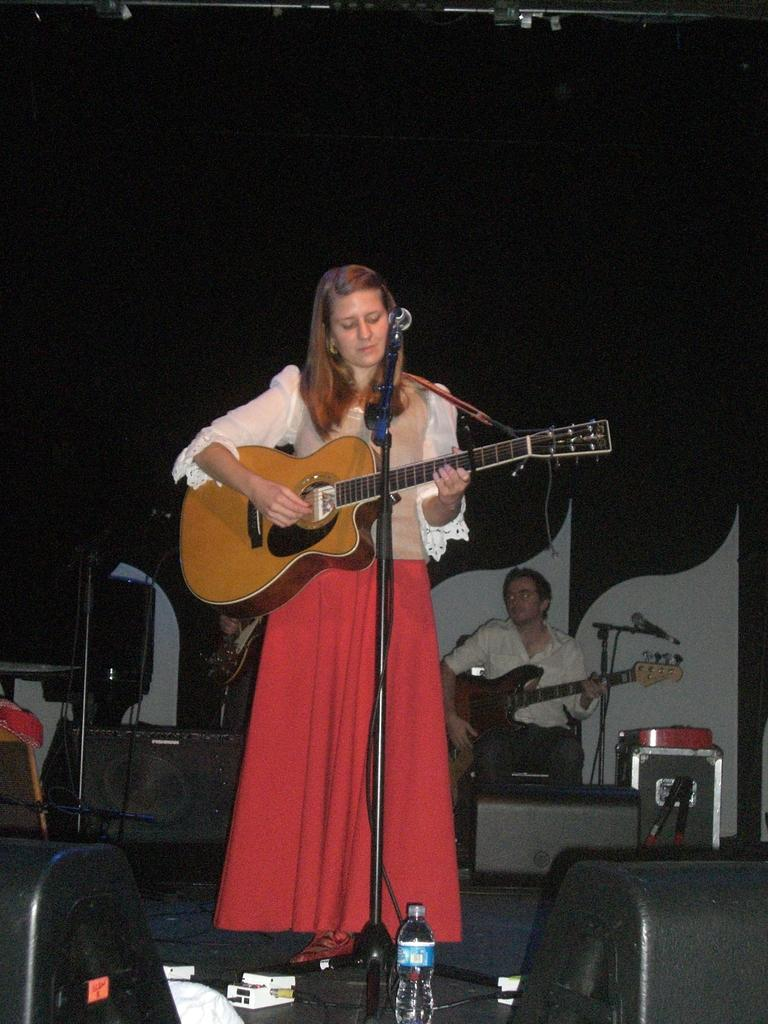What is the woman in the image holding? The woman is holding a guitar. What object is in front of the woman? There is a microphone in front of the woman. What is on the ground in front of the woman? There is a bottle in front of the woman. Who else is in the image? There is a man in the image. What is the man holding? The man is holding a guitar. Where is the man positioned in relation to the woman? The man is behind the woman. What type of mask is the woman wearing in the image? There is no mask present in the image; the woman is not wearing any mask. What does the stage look like in the image? There is no stage present in the image; it appears to be a regular room or setting. 